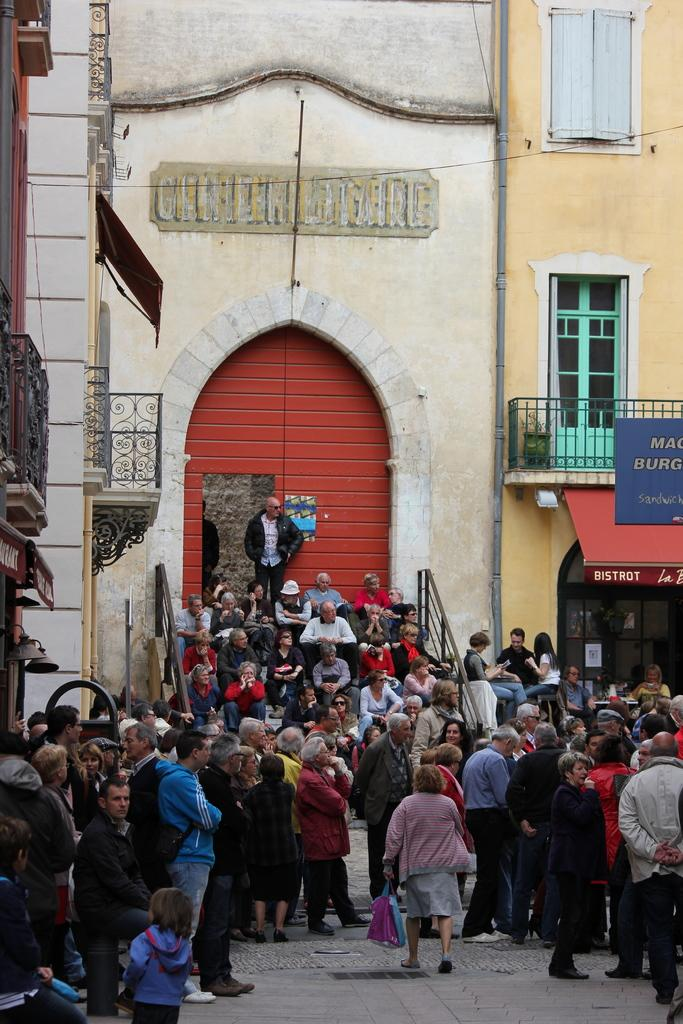What are the people in the image doing? There are persons standing and sitting in the image. Where are the persons sitting? The persons are sitting on a staircase in the image. What can be seen in the background of the image? There are buildings on either side of the persons in the image. What type of string is being used to hold up the arch in the image? There is no arch or string present in the image. 